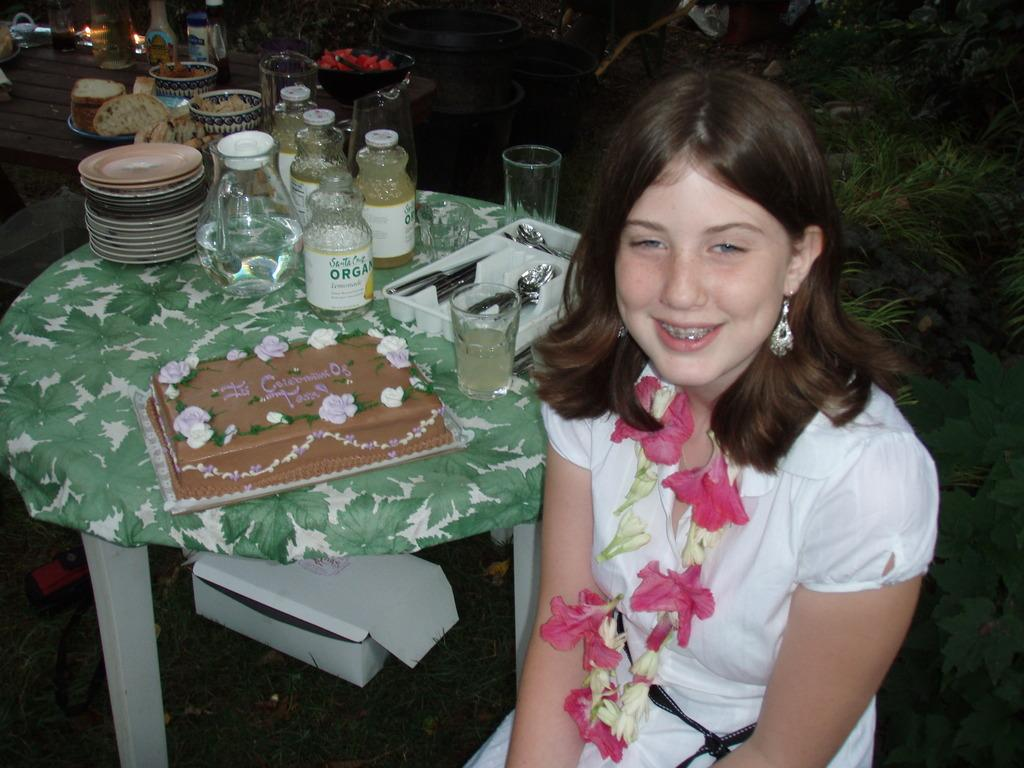Who is in the picture? There is a girl in the picture. What is the girl doing in the picture? The girl is smiling. What can be seen on the table in the image? There is a water jar, spoons, plates, water glasses, and a cake on the table. How many items are on the table? There are six items on the table: a water jar, spoons, plates, water glasses, and a cake. What type of trade is being conducted in the image? There is no trade being conducted in the image; it features a girl smiling and a table with various items. Is there a lamp present in the image? No, there is no lamp present in the image. 